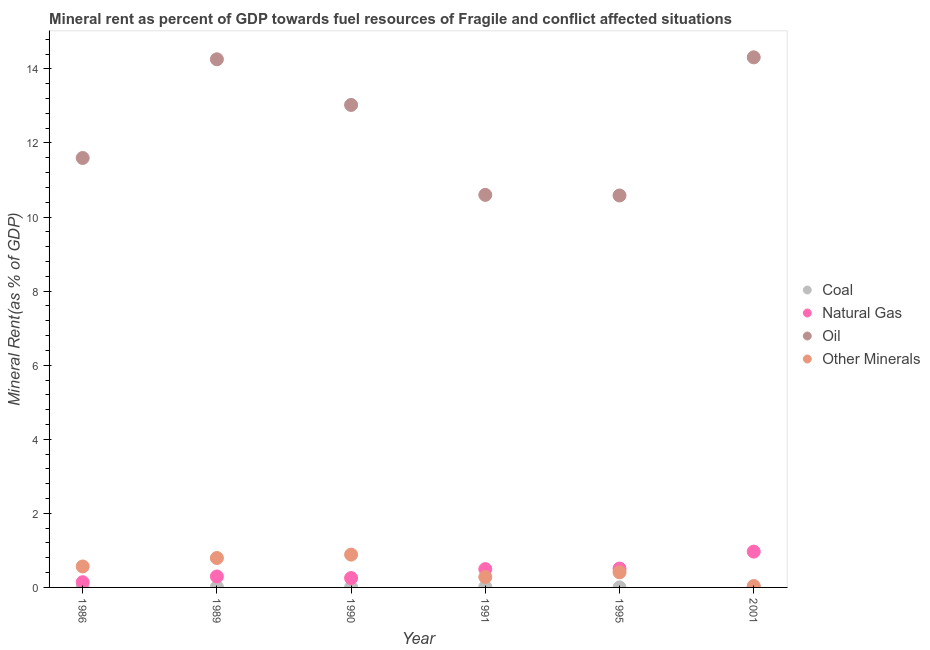Is the number of dotlines equal to the number of legend labels?
Offer a very short reply. Yes. What is the  rent of other minerals in 1995?
Offer a very short reply. 0.41. Across all years, what is the maximum natural gas rent?
Your answer should be compact. 0.97. Across all years, what is the minimum oil rent?
Give a very brief answer. 10.58. What is the total natural gas rent in the graph?
Your response must be concise. 2.66. What is the difference between the  rent of other minerals in 1986 and that in 2001?
Your answer should be compact. 0.53. What is the difference between the coal rent in 1989 and the oil rent in 1991?
Provide a succinct answer. -10.59. What is the average  rent of other minerals per year?
Give a very brief answer. 0.5. In the year 1995, what is the difference between the  rent of other minerals and coal rent?
Make the answer very short. 0.41. In how many years, is the coal rent greater than 8 %?
Make the answer very short. 0. What is the ratio of the natural gas rent in 1989 to that in 1991?
Keep it short and to the point. 0.6. Is the natural gas rent in 1989 less than that in 1995?
Your response must be concise. Yes. Is the difference between the  rent of other minerals in 1989 and 1991 greater than the difference between the oil rent in 1989 and 1991?
Make the answer very short. No. What is the difference between the highest and the second highest natural gas rent?
Give a very brief answer. 0.46. What is the difference between the highest and the lowest coal rent?
Your response must be concise. 0.01. In how many years, is the  rent of other minerals greater than the average  rent of other minerals taken over all years?
Provide a succinct answer. 3. Is the sum of the oil rent in 1989 and 2001 greater than the maximum natural gas rent across all years?
Provide a short and direct response. Yes. Is it the case that in every year, the sum of the coal rent and  rent of other minerals is greater than the sum of natural gas rent and oil rent?
Keep it short and to the point. No. Is it the case that in every year, the sum of the coal rent and natural gas rent is greater than the oil rent?
Your response must be concise. No. Does the coal rent monotonically increase over the years?
Provide a short and direct response. No. Is the coal rent strictly greater than the oil rent over the years?
Ensure brevity in your answer.  No. Is the  rent of other minerals strictly less than the coal rent over the years?
Make the answer very short. No. Are the values on the major ticks of Y-axis written in scientific E-notation?
Give a very brief answer. No. How are the legend labels stacked?
Your response must be concise. Vertical. What is the title of the graph?
Offer a very short reply. Mineral rent as percent of GDP towards fuel resources of Fragile and conflict affected situations. What is the label or title of the X-axis?
Offer a terse response. Year. What is the label or title of the Y-axis?
Your answer should be compact. Mineral Rent(as % of GDP). What is the Mineral Rent(as % of GDP) of Coal in 1986?
Your answer should be very brief. 0.01. What is the Mineral Rent(as % of GDP) of Natural Gas in 1986?
Ensure brevity in your answer.  0.14. What is the Mineral Rent(as % of GDP) in Oil in 1986?
Provide a short and direct response. 11.6. What is the Mineral Rent(as % of GDP) in Other Minerals in 1986?
Your response must be concise. 0.57. What is the Mineral Rent(as % of GDP) of Coal in 1989?
Provide a short and direct response. 0.01. What is the Mineral Rent(as % of GDP) in Natural Gas in 1989?
Offer a very short reply. 0.3. What is the Mineral Rent(as % of GDP) in Oil in 1989?
Your response must be concise. 14.26. What is the Mineral Rent(as % of GDP) in Other Minerals in 1989?
Offer a very short reply. 0.79. What is the Mineral Rent(as % of GDP) in Coal in 1990?
Ensure brevity in your answer.  0.01. What is the Mineral Rent(as % of GDP) in Natural Gas in 1990?
Keep it short and to the point. 0.25. What is the Mineral Rent(as % of GDP) in Oil in 1990?
Provide a succinct answer. 13.03. What is the Mineral Rent(as % of GDP) in Other Minerals in 1990?
Give a very brief answer. 0.89. What is the Mineral Rent(as % of GDP) in Coal in 1991?
Provide a short and direct response. 0.01. What is the Mineral Rent(as % of GDP) of Natural Gas in 1991?
Your answer should be very brief. 0.49. What is the Mineral Rent(as % of GDP) of Oil in 1991?
Your answer should be very brief. 10.6. What is the Mineral Rent(as % of GDP) of Other Minerals in 1991?
Your answer should be compact. 0.28. What is the Mineral Rent(as % of GDP) of Coal in 1995?
Offer a terse response. 0. What is the Mineral Rent(as % of GDP) in Natural Gas in 1995?
Make the answer very short. 0.51. What is the Mineral Rent(as % of GDP) in Oil in 1995?
Your answer should be compact. 10.58. What is the Mineral Rent(as % of GDP) in Other Minerals in 1995?
Your answer should be very brief. 0.41. What is the Mineral Rent(as % of GDP) in Coal in 2001?
Offer a very short reply. 0.01. What is the Mineral Rent(as % of GDP) of Natural Gas in 2001?
Your response must be concise. 0.97. What is the Mineral Rent(as % of GDP) of Oil in 2001?
Your response must be concise. 14.31. What is the Mineral Rent(as % of GDP) in Other Minerals in 2001?
Provide a short and direct response. 0.04. Across all years, what is the maximum Mineral Rent(as % of GDP) of Coal?
Give a very brief answer. 0.01. Across all years, what is the maximum Mineral Rent(as % of GDP) in Natural Gas?
Your answer should be compact. 0.97. Across all years, what is the maximum Mineral Rent(as % of GDP) in Oil?
Offer a terse response. 14.31. Across all years, what is the maximum Mineral Rent(as % of GDP) in Other Minerals?
Your answer should be very brief. 0.89. Across all years, what is the minimum Mineral Rent(as % of GDP) in Coal?
Your answer should be very brief. 0. Across all years, what is the minimum Mineral Rent(as % of GDP) of Natural Gas?
Your answer should be very brief. 0.14. Across all years, what is the minimum Mineral Rent(as % of GDP) of Oil?
Give a very brief answer. 10.58. Across all years, what is the minimum Mineral Rent(as % of GDP) in Other Minerals?
Your answer should be very brief. 0.04. What is the total Mineral Rent(as % of GDP) of Coal in the graph?
Offer a very short reply. 0.05. What is the total Mineral Rent(as % of GDP) in Natural Gas in the graph?
Offer a very short reply. 2.66. What is the total Mineral Rent(as % of GDP) in Oil in the graph?
Your answer should be very brief. 74.38. What is the total Mineral Rent(as % of GDP) of Other Minerals in the graph?
Your answer should be very brief. 2.97. What is the difference between the Mineral Rent(as % of GDP) of Coal in 1986 and that in 1989?
Your response must be concise. 0. What is the difference between the Mineral Rent(as % of GDP) of Natural Gas in 1986 and that in 1989?
Your response must be concise. -0.15. What is the difference between the Mineral Rent(as % of GDP) of Oil in 1986 and that in 1989?
Make the answer very short. -2.66. What is the difference between the Mineral Rent(as % of GDP) of Other Minerals in 1986 and that in 1989?
Offer a terse response. -0.23. What is the difference between the Mineral Rent(as % of GDP) in Coal in 1986 and that in 1990?
Your answer should be compact. 0. What is the difference between the Mineral Rent(as % of GDP) of Natural Gas in 1986 and that in 1990?
Your response must be concise. -0.11. What is the difference between the Mineral Rent(as % of GDP) of Oil in 1986 and that in 1990?
Your answer should be compact. -1.43. What is the difference between the Mineral Rent(as % of GDP) in Other Minerals in 1986 and that in 1990?
Your answer should be very brief. -0.32. What is the difference between the Mineral Rent(as % of GDP) of Coal in 1986 and that in 1991?
Your answer should be very brief. -0. What is the difference between the Mineral Rent(as % of GDP) of Natural Gas in 1986 and that in 1991?
Your answer should be very brief. -0.35. What is the difference between the Mineral Rent(as % of GDP) in Oil in 1986 and that in 1991?
Give a very brief answer. 1. What is the difference between the Mineral Rent(as % of GDP) in Other Minerals in 1986 and that in 1991?
Give a very brief answer. 0.28. What is the difference between the Mineral Rent(as % of GDP) in Coal in 1986 and that in 1995?
Offer a terse response. 0.01. What is the difference between the Mineral Rent(as % of GDP) in Natural Gas in 1986 and that in 1995?
Ensure brevity in your answer.  -0.37. What is the difference between the Mineral Rent(as % of GDP) in Other Minerals in 1986 and that in 1995?
Offer a terse response. 0.16. What is the difference between the Mineral Rent(as % of GDP) in Coal in 1986 and that in 2001?
Give a very brief answer. -0. What is the difference between the Mineral Rent(as % of GDP) in Natural Gas in 1986 and that in 2001?
Give a very brief answer. -0.83. What is the difference between the Mineral Rent(as % of GDP) of Oil in 1986 and that in 2001?
Your answer should be compact. -2.72. What is the difference between the Mineral Rent(as % of GDP) of Other Minerals in 1986 and that in 2001?
Offer a very short reply. 0.53. What is the difference between the Mineral Rent(as % of GDP) of Coal in 1989 and that in 1990?
Your answer should be compact. 0. What is the difference between the Mineral Rent(as % of GDP) of Natural Gas in 1989 and that in 1990?
Offer a terse response. 0.04. What is the difference between the Mineral Rent(as % of GDP) in Oil in 1989 and that in 1990?
Offer a very short reply. 1.23. What is the difference between the Mineral Rent(as % of GDP) in Other Minerals in 1989 and that in 1990?
Give a very brief answer. -0.09. What is the difference between the Mineral Rent(as % of GDP) of Coal in 1989 and that in 1991?
Ensure brevity in your answer.  -0.01. What is the difference between the Mineral Rent(as % of GDP) in Natural Gas in 1989 and that in 1991?
Provide a succinct answer. -0.2. What is the difference between the Mineral Rent(as % of GDP) in Oil in 1989 and that in 1991?
Your response must be concise. 3.66. What is the difference between the Mineral Rent(as % of GDP) in Other Minerals in 1989 and that in 1991?
Ensure brevity in your answer.  0.51. What is the difference between the Mineral Rent(as % of GDP) of Coal in 1989 and that in 1995?
Offer a terse response. 0.01. What is the difference between the Mineral Rent(as % of GDP) in Natural Gas in 1989 and that in 1995?
Provide a short and direct response. -0.21. What is the difference between the Mineral Rent(as % of GDP) of Oil in 1989 and that in 1995?
Provide a short and direct response. 3.68. What is the difference between the Mineral Rent(as % of GDP) in Other Minerals in 1989 and that in 1995?
Your response must be concise. 0.39. What is the difference between the Mineral Rent(as % of GDP) of Coal in 1989 and that in 2001?
Your answer should be compact. -0. What is the difference between the Mineral Rent(as % of GDP) of Natural Gas in 1989 and that in 2001?
Offer a terse response. -0.67. What is the difference between the Mineral Rent(as % of GDP) of Oil in 1989 and that in 2001?
Ensure brevity in your answer.  -0.05. What is the difference between the Mineral Rent(as % of GDP) in Other Minerals in 1989 and that in 2001?
Your answer should be very brief. 0.76. What is the difference between the Mineral Rent(as % of GDP) of Coal in 1990 and that in 1991?
Provide a succinct answer. -0.01. What is the difference between the Mineral Rent(as % of GDP) of Natural Gas in 1990 and that in 1991?
Your answer should be very brief. -0.24. What is the difference between the Mineral Rent(as % of GDP) of Oil in 1990 and that in 1991?
Provide a succinct answer. 2.43. What is the difference between the Mineral Rent(as % of GDP) of Other Minerals in 1990 and that in 1991?
Keep it short and to the point. 0.6. What is the difference between the Mineral Rent(as % of GDP) in Coal in 1990 and that in 1995?
Give a very brief answer. 0. What is the difference between the Mineral Rent(as % of GDP) in Natural Gas in 1990 and that in 1995?
Your answer should be compact. -0.26. What is the difference between the Mineral Rent(as % of GDP) of Oil in 1990 and that in 1995?
Give a very brief answer. 2.44. What is the difference between the Mineral Rent(as % of GDP) of Other Minerals in 1990 and that in 1995?
Keep it short and to the point. 0.48. What is the difference between the Mineral Rent(as % of GDP) in Coal in 1990 and that in 2001?
Your answer should be very brief. -0. What is the difference between the Mineral Rent(as % of GDP) in Natural Gas in 1990 and that in 2001?
Ensure brevity in your answer.  -0.71. What is the difference between the Mineral Rent(as % of GDP) of Oil in 1990 and that in 2001?
Provide a short and direct response. -1.29. What is the difference between the Mineral Rent(as % of GDP) in Other Minerals in 1990 and that in 2001?
Ensure brevity in your answer.  0.85. What is the difference between the Mineral Rent(as % of GDP) of Coal in 1991 and that in 1995?
Your answer should be compact. 0.01. What is the difference between the Mineral Rent(as % of GDP) in Natural Gas in 1991 and that in 1995?
Provide a succinct answer. -0.02. What is the difference between the Mineral Rent(as % of GDP) in Oil in 1991 and that in 1995?
Your response must be concise. 0.02. What is the difference between the Mineral Rent(as % of GDP) of Other Minerals in 1991 and that in 1995?
Provide a succinct answer. -0.13. What is the difference between the Mineral Rent(as % of GDP) of Coal in 1991 and that in 2001?
Your response must be concise. 0. What is the difference between the Mineral Rent(as % of GDP) in Natural Gas in 1991 and that in 2001?
Provide a succinct answer. -0.47. What is the difference between the Mineral Rent(as % of GDP) in Oil in 1991 and that in 2001?
Provide a short and direct response. -3.71. What is the difference between the Mineral Rent(as % of GDP) of Other Minerals in 1991 and that in 2001?
Offer a terse response. 0.24. What is the difference between the Mineral Rent(as % of GDP) of Coal in 1995 and that in 2001?
Your answer should be compact. -0.01. What is the difference between the Mineral Rent(as % of GDP) of Natural Gas in 1995 and that in 2001?
Your answer should be very brief. -0.46. What is the difference between the Mineral Rent(as % of GDP) of Oil in 1995 and that in 2001?
Provide a short and direct response. -3.73. What is the difference between the Mineral Rent(as % of GDP) of Other Minerals in 1995 and that in 2001?
Your response must be concise. 0.37. What is the difference between the Mineral Rent(as % of GDP) of Coal in 1986 and the Mineral Rent(as % of GDP) of Natural Gas in 1989?
Offer a terse response. -0.29. What is the difference between the Mineral Rent(as % of GDP) of Coal in 1986 and the Mineral Rent(as % of GDP) of Oil in 1989?
Offer a terse response. -14.25. What is the difference between the Mineral Rent(as % of GDP) of Coal in 1986 and the Mineral Rent(as % of GDP) of Other Minerals in 1989?
Offer a terse response. -0.78. What is the difference between the Mineral Rent(as % of GDP) of Natural Gas in 1986 and the Mineral Rent(as % of GDP) of Oil in 1989?
Your answer should be very brief. -14.12. What is the difference between the Mineral Rent(as % of GDP) of Natural Gas in 1986 and the Mineral Rent(as % of GDP) of Other Minerals in 1989?
Your answer should be compact. -0.65. What is the difference between the Mineral Rent(as % of GDP) in Oil in 1986 and the Mineral Rent(as % of GDP) in Other Minerals in 1989?
Offer a very short reply. 10.8. What is the difference between the Mineral Rent(as % of GDP) in Coal in 1986 and the Mineral Rent(as % of GDP) in Natural Gas in 1990?
Your response must be concise. -0.24. What is the difference between the Mineral Rent(as % of GDP) of Coal in 1986 and the Mineral Rent(as % of GDP) of Oil in 1990?
Give a very brief answer. -13.02. What is the difference between the Mineral Rent(as % of GDP) in Coal in 1986 and the Mineral Rent(as % of GDP) in Other Minerals in 1990?
Offer a terse response. -0.88. What is the difference between the Mineral Rent(as % of GDP) in Natural Gas in 1986 and the Mineral Rent(as % of GDP) in Oil in 1990?
Your response must be concise. -12.89. What is the difference between the Mineral Rent(as % of GDP) in Natural Gas in 1986 and the Mineral Rent(as % of GDP) in Other Minerals in 1990?
Make the answer very short. -0.75. What is the difference between the Mineral Rent(as % of GDP) in Oil in 1986 and the Mineral Rent(as % of GDP) in Other Minerals in 1990?
Make the answer very short. 10.71. What is the difference between the Mineral Rent(as % of GDP) in Coal in 1986 and the Mineral Rent(as % of GDP) in Natural Gas in 1991?
Provide a short and direct response. -0.48. What is the difference between the Mineral Rent(as % of GDP) in Coal in 1986 and the Mineral Rent(as % of GDP) in Oil in 1991?
Offer a terse response. -10.59. What is the difference between the Mineral Rent(as % of GDP) in Coal in 1986 and the Mineral Rent(as % of GDP) in Other Minerals in 1991?
Your answer should be very brief. -0.27. What is the difference between the Mineral Rent(as % of GDP) in Natural Gas in 1986 and the Mineral Rent(as % of GDP) in Oil in 1991?
Keep it short and to the point. -10.46. What is the difference between the Mineral Rent(as % of GDP) of Natural Gas in 1986 and the Mineral Rent(as % of GDP) of Other Minerals in 1991?
Keep it short and to the point. -0.14. What is the difference between the Mineral Rent(as % of GDP) in Oil in 1986 and the Mineral Rent(as % of GDP) in Other Minerals in 1991?
Your answer should be compact. 11.31. What is the difference between the Mineral Rent(as % of GDP) of Coal in 1986 and the Mineral Rent(as % of GDP) of Natural Gas in 1995?
Provide a succinct answer. -0.5. What is the difference between the Mineral Rent(as % of GDP) in Coal in 1986 and the Mineral Rent(as % of GDP) in Oil in 1995?
Ensure brevity in your answer.  -10.57. What is the difference between the Mineral Rent(as % of GDP) in Coal in 1986 and the Mineral Rent(as % of GDP) in Other Minerals in 1995?
Your response must be concise. -0.4. What is the difference between the Mineral Rent(as % of GDP) in Natural Gas in 1986 and the Mineral Rent(as % of GDP) in Oil in 1995?
Offer a terse response. -10.44. What is the difference between the Mineral Rent(as % of GDP) in Natural Gas in 1986 and the Mineral Rent(as % of GDP) in Other Minerals in 1995?
Offer a terse response. -0.27. What is the difference between the Mineral Rent(as % of GDP) of Oil in 1986 and the Mineral Rent(as % of GDP) of Other Minerals in 1995?
Provide a short and direct response. 11.19. What is the difference between the Mineral Rent(as % of GDP) of Coal in 1986 and the Mineral Rent(as % of GDP) of Natural Gas in 2001?
Your answer should be very brief. -0.96. What is the difference between the Mineral Rent(as % of GDP) in Coal in 1986 and the Mineral Rent(as % of GDP) in Oil in 2001?
Provide a succinct answer. -14.3. What is the difference between the Mineral Rent(as % of GDP) of Coal in 1986 and the Mineral Rent(as % of GDP) of Other Minerals in 2001?
Your response must be concise. -0.03. What is the difference between the Mineral Rent(as % of GDP) of Natural Gas in 1986 and the Mineral Rent(as % of GDP) of Oil in 2001?
Your answer should be compact. -14.17. What is the difference between the Mineral Rent(as % of GDP) of Natural Gas in 1986 and the Mineral Rent(as % of GDP) of Other Minerals in 2001?
Provide a short and direct response. 0.1. What is the difference between the Mineral Rent(as % of GDP) in Oil in 1986 and the Mineral Rent(as % of GDP) in Other Minerals in 2001?
Give a very brief answer. 11.56. What is the difference between the Mineral Rent(as % of GDP) in Coal in 1989 and the Mineral Rent(as % of GDP) in Natural Gas in 1990?
Your answer should be very brief. -0.25. What is the difference between the Mineral Rent(as % of GDP) in Coal in 1989 and the Mineral Rent(as % of GDP) in Oil in 1990?
Your answer should be compact. -13.02. What is the difference between the Mineral Rent(as % of GDP) in Coal in 1989 and the Mineral Rent(as % of GDP) in Other Minerals in 1990?
Offer a terse response. -0.88. What is the difference between the Mineral Rent(as % of GDP) of Natural Gas in 1989 and the Mineral Rent(as % of GDP) of Oil in 1990?
Ensure brevity in your answer.  -12.73. What is the difference between the Mineral Rent(as % of GDP) in Natural Gas in 1989 and the Mineral Rent(as % of GDP) in Other Minerals in 1990?
Provide a short and direct response. -0.59. What is the difference between the Mineral Rent(as % of GDP) in Oil in 1989 and the Mineral Rent(as % of GDP) in Other Minerals in 1990?
Offer a very short reply. 13.37. What is the difference between the Mineral Rent(as % of GDP) of Coal in 1989 and the Mineral Rent(as % of GDP) of Natural Gas in 1991?
Offer a very short reply. -0.49. What is the difference between the Mineral Rent(as % of GDP) in Coal in 1989 and the Mineral Rent(as % of GDP) in Oil in 1991?
Offer a very short reply. -10.59. What is the difference between the Mineral Rent(as % of GDP) in Coal in 1989 and the Mineral Rent(as % of GDP) in Other Minerals in 1991?
Your response must be concise. -0.27. What is the difference between the Mineral Rent(as % of GDP) in Natural Gas in 1989 and the Mineral Rent(as % of GDP) in Oil in 1991?
Your answer should be very brief. -10.3. What is the difference between the Mineral Rent(as % of GDP) of Natural Gas in 1989 and the Mineral Rent(as % of GDP) of Other Minerals in 1991?
Provide a succinct answer. 0.01. What is the difference between the Mineral Rent(as % of GDP) in Oil in 1989 and the Mineral Rent(as % of GDP) in Other Minerals in 1991?
Keep it short and to the point. 13.98. What is the difference between the Mineral Rent(as % of GDP) in Coal in 1989 and the Mineral Rent(as % of GDP) in Natural Gas in 1995?
Your answer should be compact. -0.5. What is the difference between the Mineral Rent(as % of GDP) in Coal in 1989 and the Mineral Rent(as % of GDP) in Oil in 1995?
Keep it short and to the point. -10.57. What is the difference between the Mineral Rent(as % of GDP) in Coal in 1989 and the Mineral Rent(as % of GDP) in Other Minerals in 1995?
Offer a terse response. -0.4. What is the difference between the Mineral Rent(as % of GDP) in Natural Gas in 1989 and the Mineral Rent(as % of GDP) in Oil in 1995?
Keep it short and to the point. -10.29. What is the difference between the Mineral Rent(as % of GDP) in Natural Gas in 1989 and the Mineral Rent(as % of GDP) in Other Minerals in 1995?
Give a very brief answer. -0.11. What is the difference between the Mineral Rent(as % of GDP) in Oil in 1989 and the Mineral Rent(as % of GDP) in Other Minerals in 1995?
Provide a short and direct response. 13.85. What is the difference between the Mineral Rent(as % of GDP) of Coal in 1989 and the Mineral Rent(as % of GDP) of Natural Gas in 2001?
Give a very brief answer. -0.96. What is the difference between the Mineral Rent(as % of GDP) in Coal in 1989 and the Mineral Rent(as % of GDP) in Oil in 2001?
Offer a very short reply. -14.3. What is the difference between the Mineral Rent(as % of GDP) of Coal in 1989 and the Mineral Rent(as % of GDP) of Other Minerals in 2001?
Offer a terse response. -0.03. What is the difference between the Mineral Rent(as % of GDP) in Natural Gas in 1989 and the Mineral Rent(as % of GDP) in Oil in 2001?
Offer a terse response. -14.02. What is the difference between the Mineral Rent(as % of GDP) of Natural Gas in 1989 and the Mineral Rent(as % of GDP) of Other Minerals in 2001?
Provide a short and direct response. 0.26. What is the difference between the Mineral Rent(as % of GDP) of Oil in 1989 and the Mineral Rent(as % of GDP) of Other Minerals in 2001?
Provide a short and direct response. 14.22. What is the difference between the Mineral Rent(as % of GDP) of Coal in 1990 and the Mineral Rent(as % of GDP) of Natural Gas in 1991?
Your answer should be compact. -0.49. What is the difference between the Mineral Rent(as % of GDP) of Coal in 1990 and the Mineral Rent(as % of GDP) of Oil in 1991?
Offer a very short reply. -10.59. What is the difference between the Mineral Rent(as % of GDP) of Coal in 1990 and the Mineral Rent(as % of GDP) of Other Minerals in 1991?
Offer a terse response. -0.28. What is the difference between the Mineral Rent(as % of GDP) in Natural Gas in 1990 and the Mineral Rent(as % of GDP) in Oil in 1991?
Your answer should be very brief. -10.35. What is the difference between the Mineral Rent(as % of GDP) of Natural Gas in 1990 and the Mineral Rent(as % of GDP) of Other Minerals in 1991?
Provide a short and direct response. -0.03. What is the difference between the Mineral Rent(as % of GDP) of Oil in 1990 and the Mineral Rent(as % of GDP) of Other Minerals in 1991?
Your answer should be compact. 12.75. What is the difference between the Mineral Rent(as % of GDP) of Coal in 1990 and the Mineral Rent(as % of GDP) of Natural Gas in 1995?
Offer a terse response. -0.5. What is the difference between the Mineral Rent(as % of GDP) of Coal in 1990 and the Mineral Rent(as % of GDP) of Oil in 1995?
Keep it short and to the point. -10.58. What is the difference between the Mineral Rent(as % of GDP) in Coal in 1990 and the Mineral Rent(as % of GDP) in Other Minerals in 1995?
Your answer should be compact. -0.4. What is the difference between the Mineral Rent(as % of GDP) of Natural Gas in 1990 and the Mineral Rent(as % of GDP) of Oil in 1995?
Your response must be concise. -10.33. What is the difference between the Mineral Rent(as % of GDP) in Natural Gas in 1990 and the Mineral Rent(as % of GDP) in Other Minerals in 1995?
Your answer should be very brief. -0.15. What is the difference between the Mineral Rent(as % of GDP) in Oil in 1990 and the Mineral Rent(as % of GDP) in Other Minerals in 1995?
Make the answer very short. 12.62. What is the difference between the Mineral Rent(as % of GDP) in Coal in 1990 and the Mineral Rent(as % of GDP) in Natural Gas in 2001?
Make the answer very short. -0.96. What is the difference between the Mineral Rent(as % of GDP) of Coal in 1990 and the Mineral Rent(as % of GDP) of Oil in 2001?
Your response must be concise. -14.31. What is the difference between the Mineral Rent(as % of GDP) in Coal in 1990 and the Mineral Rent(as % of GDP) in Other Minerals in 2001?
Keep it short and to the point. -0.03. What is the difference between the Mineral Rent(as % of GDP) in Natural Gas in 1990 and the Mineral Rent(as % of GDP) in Oil in 2001?
Your response must be concise. -14.06. What is the difference between the Mineral Rent(as % of GDP) of Natural Gas in 1990 and the Mineral Rent(as % of GDP) of Other Minerals in 2001?
Keep it short and to the point. 0.22. What is the difference between the Mineral Rent(as % of GDP) of Oil in 1990 and the Mineral Rent(as % of GDP) of Other Minerals in 2001?
Provide a succinct answer. 12.99. What is the difference between the Mineral Rent(as % of GDP) in Coal in 1991 and the Mineral Rent(as % of GDP) in Natural Gas in 1995?
Offer a very short reply. -0.5. What is the difference between the Mineral Rent(as % of GDP) of Coal in 1991 and the Mineral Rent(as % of GDP) of Oil in 1995?
Your answer should be compact. -10.57. What is the difference between the Mineral Rent(as % of GDP) of Coal in 1991 and the Mineral Rent(as % of GDP) of Other Minerals in 1995?
Provide a short and direct response. -0.39. What is the difference between the Mineral Rent(as % of GDP) of Natural Gas in 1991 and the Mineral Rent(as % of GDP) of Oil in 1995?
Your answer should be very brief. -10.09. What is the difference between the Mineral Rent(as % of GDP) of Natural Gas in 1991 and the Mineral Rent(as % of GDP) of Other Minerals in 1995?
Give a very brief answer. 0.09. What is the difference between the Mineral Rent(as % of GDP) of Oil in 1991 and the Mineral Rent(as % of GDP) of Other Minerals in 1995?
Your response must be concise. 10.19. What is the difference between the Mineral Rent(as % of GDP) in Coal in 1991 and the Mineral Rent(as % of GDP) in Natural Gas in 2001?
Ensure brevity in your answer.  -0.95. What is the difference between the Mineral Rent(as % of GDP) in Coal in 1991 and the Mineral Rent(as % of GDP) in Oil in 2001?
Offer a terse response. -14.3. What is the difference between the Mineral Rent(as % of GDP) of Coal in 1991 and the Mineral Rent(as % of GDP) of Other Minerals in 2001?
Your answer should be very brief. -0.02. What is the difference between the Mineral Rent(as % of GDP) of Natural Gas in 1991 and the Mineral Rent(as % of GDP) of Oil in 2001?
Your answer should be very brief. -13.82. What is the difference between the Mineral Rent(as % of GDP) in Natural Gas in 1991 and the Mineral Rent(as % of GDP) in Other Minerals in 2001?
Offer a very short reply. 0.46. What is the difference between the Mineral Rent(as % of GDP) in Oil in 1991 and the Mineral Rent(as % of GDP) in Other Minerals in 2001?
Make the answer very short. 10.56. What is the difference between the Mineral Rent(as % of GDP) of Coal in 1995 and the Mineral Rent(as % of GDP) of Natural Gas in 2001?
Keep it short and to the point. -0.97. What is the difference between the Mineral Rent(as % of GDP) of Coal in 1995 and the Mineral Rent(as % of GDP) of Oil in 2001?
Give a very brief answer. -14.31. What is the difference between the Mineral Rent(as % of GDP) of Coal in 1995 and the Mineral Rent(as % of GDP) of Other Minerals in 2001?
Keep it short and to the point. -0.04. What is the difference between the Mineral Rent(as % of GDP) in Natural Gas in 1995 and the Mineral Rent(as % of GDP) in Oil in 2001?
Your answer should be compact. -13.8. What is the difference between the Mineral Rent(as % of GDP) of Natural Gas in 1995 and the Mineral Rent(as % of GDP) of Other Minerals in 2001?
Give a very brief answer. 0.47. What is the difference between the Mineral Rent(as % of GDP) in Oil in 1995 and the Mineral Rent(as % of GDP) in Other Minerals in 2001?
Offer a terse response. 10.54. What is the average Mineral Rent(as % of GDP) of Coal per year?
Ensure brevity in your answer.  0.01. What is the average Mineral Rent(as % of GDP) in Natural Gas per year?
Your answer should be compact. 0.44. What is the average Mineral Rent(as % of GDP) of Oil per year?
Keep it short and to the point. 12.4. What is the average Mineral Rent(as % of GDP) in Other Minerals per year?
Your answer should be very brief. 0.5. In the year 1986, what is the difference between the Mineral Rent(as % of GDP) in Coal and Mineral Rent(as % of GDP) in Natural Gas?
Give a very brief answer. -0.13. In the year 1986, what is the difference between the Mineral Rent(as % of GDP) of Coal and Mineral Rent(as % of GDP) of Oil?
Keep it short and to the point. -11.59. In the year 1986, what is the difference between the Mineral Rent(as % of GDP) of Coal and Mineral Rent(as % of GDP) of Other Minerals?
Offer a terse response. -0.56. In the year 1986, what is the difference between the Mineral Rent(as % of GDP) in Natural Gas and Mineral Rent(as % of GDP) in Oil?
Give a very brief answer. -11.45. In the year 1986, what is the difference between the Mineral Rent(as % of GDP) of Natural Gas and Mineral Rent(as % of GDP) of Other Minerals?
Keep it short and to the point. -0.42. In the year 1986, what is the difference between the Mineral Rent(as % of GDP) in Oil and Mineral Rent(as % of GDP) in Other Minerals?
Ensure brevity in your answer.  11.03. In the year 1989, what is the difference between the Mineral Rent(as % of GDP) in Coal and Mineral Rent(as % of GDP) in Natural Gas?
Offer a terse response. -0.29. In the year 1989, what is the difference between the Mineral Rent(as % of GDP) of Coal and Mineral Rent(as % of GDP) of Oil?
Offer a very short reply. -14.25. In the year 1989, what is the difference between the Mineral Rent(as % of GDP) of Coal and Mineral Rent(as % of GDP) of Other Minerals?
Make the answer very short. -0.79. In the year 1989, what is the difference between the Mineral Rent(as % of GDP) of Natural Gas and Mineral Rent(as % of GDP) of Oil?
Provide a succinct answer. -13.96. In the year 1989, what is the difference between the Mineral Rent(as % of GDP) in Natural Gas and Mineral Rent(as % of GDP) in Other Minerals?
Keep it short and to the point. -0.5. In the year 1989, what is the difference between the Mineral Rent(as % of GDP) of Oil and Mineral Rent(as % of GDP) of Other Minerals?
Make the answer very short. 13.47. In the year 1990, what is the difference between the Mineral Rent(as % of GDP) of Coal and Mineral Rent(as % of GDP) of Natural Gas?
Provide a short and direct response. -0.25. In the year 1990, what is the difference between the Mineral Rent(as % of GDP) of Coal and Mineral Rent(as % of GDP) of Oil?
Your answer should be very brief. -13.02. In the year 1990, what is the difference between the Mineral Rent(as % of GDP) in Coal and Mineral Rent(as % of GDP) in Other Minerals?
Offer a terse response. -0.88. In the year 1990, what is the difference between the Mineral Rent(as % of GDP) of Natural Gas and Mineral Rent(as % of GDP) of Oil?
Provide a short and direct response. -12.77. In the year 1990, what is the difference between the Mineral Rent(as % of GDP) of Natural Gas and Mineral Rent(as % of GDP) of Other Minerals?
Provide a short and direct response. -0.63. In the year 1990, what is the difference between the Mineral Rent(as % of GDP) in Oil and Mineral Rent(as % of GDP) in Other Minerals?
Your response must be concise. 12.14. In the year 1991, what is the difference between the Mineral Rent(as % of GDP) in Coal and Mineral Rent(as % of GDP) in Natural Gas?
Give a very brief answer. -0.48. In the year 1991, what is the difference between the Mineral Rent(as % of GDP) in Coal and Mineral Rent(as % of GDP) in Oil?
Keep it short and to the point. -10.58. In the year 1991, what is the difference between the Mineral Rent(as % of GDP) of Coal and Mineral Rent(as % of GDP) of Other Minerals?
Offer a very short reply. -0.27. In the year 1991, what is the difference between the Mineral Rent(as % of GDP) in Natural Gas and Mineral Rent(as % of GDP) in Oil?
Your response must be concise. -10.1. In the year 1991, what is the difference between the Mineral Rent(as % of GDP) of Natural Gas and Mineral Rent(as % of GDP) of Other Minerals?
Provide a succinct answer. 0.21. In the year 1991, what is the difference between the Mineral Rent(as % of GDP) of Oil and Mineral Rent(as % of GDP) of Other Minerals?
Provide a short and direct response. 10.32. In the year 1995, what is the difference between the Mineral Rent(as % of GDP) of Coal and Mineral Rent(as % of GDP) of Natural Gas?
Offer a terse response. -0.51. In the year 1995, what is the difference between the Mineral Rent(as % of GDP) in Coal and Mineral Rent(as % of GDP) in Oil?
Ensure brevity in your answer.  -10.58. In the year 1995, what is the difference between the Mineral Rent(as % of GDP) of Coal and Mineral Rent(as % of GDP) of Other Minerals?
Provide a short and direct response. -0.41. In the year 1995, what is the difference between the Mineral Rent(as % of GDP) in Natural Gas and Mineral Rent(as % of GDP) in Oil?
Your answer should be compact. -10.07. In the year 1995, what is the difference between the Mineral Rent(as % of GDP) in Natural Gas and Mineral Rent(as % of GDP) in Other Minerals?
Keep it short and to the point. 0.1. In the year 1995, what is the difference between the Mineral Rent(as % of GDP) in Oil and Mineral Rent(as % of GDP) in Other Minerals?
Provide a succinct answer. 10.17. In the year 2001, what is the difference between the Mineral Rent(as % of GDP) of Coal and Mineral Rent(as % of GDP) of Natural Gas?
Keep it short and to the point. -0.96. In the year 2001, what is the difference between the Mineral Rent(as % of GDP) of Coal and Mineral Rent(as % of GDP) of Oil?
Your answer should be very brief. -14.3. In the year 2001, what is the difference between the Mineral Rent(as % of GDP) of Coal and Mineral Rent(as % of GDP) of Other Minerals?
Your response must be concise. -0.03. In the year 2001, what is the difference between the Mineral Rent(as % of GDP) of Natural Gas and Mineral Rent(as % of GDP) of Oil?
Offer a very short reply. -13.35. In the year 2001, what is the difference between the Mineral Rent(as % of GDP) in Natural Gas and Mineral Rent(as % of GDP) in Other Minerals?
Provide a succinct answer. 0.93. In the year 2001, what is the difference between the Mineral Rent(as % of GDP) in Oil and Mineral Rent(as % of GDP) in Other Minerals?
Give a very brief answer. 14.28. What is the ratio of the Mineral Rent(as % of GDP) of Coal in 1986 to that in 1989?
Your response must be concise. 1.18. What is the ratio of the Mineral Rent(as % of GDP) in Natural Gas in 1986 to that in 1989?
Ensure brevity in your answer.  0.48. What is the ratio of the Mineral Rent(as % of GDP) in Oil in 1986 to that in 1989?
Your answer should be very brief. 0.81. What is the ratio of the Mineral Rent(as % of GDP) of Other Minerals in 1986 to that in 1989?
Your answer should be compact. 0.71. What is the ratio of the Mineral Rent(as % of GDP) of Coal in 1986 to that in 1990?
Keep it short and to the point. 1.83. What is the ratio of the Mineral Rent(as % of GDP) in Natural Gas in 1986 to that in 1990?
Your answer should be compact. 0.56. What is the ratio of the Mineral Rent(as % of GDP) in Oil in 1986 to that in 1990?
Ensure brevity in your answer.  0.89. What is the ratio of the Mineral Rent(as % of GDP) of Other Minerals in 1986 to that in 1990?
Make the answer very short. 0.64. What is the ratio of the Mineral Rent(as % of GDP) in Coal in 1986 to that in 1991?
Give a very brief answer. 0.68. What is the ratio of the Mineral Rent(as % of GDP) in Natural Gas in 1986 to that in 1991?
Ensure brevity in your answer.  0.29. What is the ratio of the Mineral Rent(as % of GDP) in Oil in 1986 to that in 1991?
Your answer should be compact. 1.09. What is the ratio of the Mineral Rent(as % of GDP) of Other Minerals in 1986 to that in 1991?
Provide a succinct answer. 2.01. What is the ratio of the Mineral Rent(as % of GDP) of Coal in 1986 to that in 1995?
Ensure brevity in your answer.  10.88. What is the ratio of the Mineral Rent(as % of GDP) of Natural Gas in 1986 to that in 1995?
Your response must be concise. 0.28. What is the ratio of the Mineral Rent(as % of GDP) of Oil in 1986 to that in 1995?
Your response must be concise. 1.1. What is the ratio of the Mineral Rent(as % of GDP) in Other Minerals in 1986 to that in 1995?
Your answer should be very brief. 1.38. What is the ratio of the Mineral Rent(as % of GDP) in Coal in 1986 to that in 2001?
Offer a terse response. 0.96. What is the ratio of the Mineral Rent(as % of GDP) in Natural Gas in 1986 to that in 2001?
Give a very brief answer. 0.15. What is the ratio of the Mineral Rent(as % of GDP) of Oil in 1986 to that in 2001?
Ensure brevity in your answer.  0.81. What is the ratio of the Mineral Rent(as % of GDP) of Other Minerals in 1986 to that in 2001?
Provide a succinct answer. 14.96. What is the ratio of the Mineral Rent(as % of GDP) in Coal in 1989 to that in 1990?
Your answer should be very brief. 1.55. What is the ratio of the Mineral Rent(as % of GDP) of Natural Gas in 1989 to that in 1990?
Provide a succinct answer. 1.17. What is the ratio of the Mineral Rent(as % of GDP) in Oil in 1989 to that in 1990?
Provide a succinct answer. 1.09. What is the ratio of the Mineral Rent(as % of GDP) of Other Minerals in 1989 to that in 1990?
Make the answer very short. 0.9. What is the ratio of the Mineral Rent(as % of GDP) in Coal in 1989 to that in 1991?
Your answer should be very brief. 0.58. What is the ratio of the Mineral Rent(as % of GDP) in Natural Gas in 1989 to that in 1991?
Offer a terse response. 0.6. What is the ratio of the Mineral Rent(as % of GDP) in Oil in 1989 to that in 1991?
Provide a short and direct response. 1.35. What is the ratio of the Mineral Rent(as % of GDP) in Other Minerals in 1989 to that in 1991?
Keep it short and to the point. 2.82. What is the ratio of the Mineral Rent(as % of GDP) of Coal in 1989 to that in 1995?
Provide a succinct answer. 9.24. What is the ratio of the Mineral Rent(as % of GDP) in Natural Gas in 1989 to that in 1995?
Give a very brief answer. 0.58. What is the ratio of the Mineral Rent(as % of GDP) in Oil in 1989 to that in 1995?
Your response must be concise. 1.35. What is the ratio of the Mineral Rent(as % of GDP) in Other Minerals in 1989 to that in 1995?
Make the answer very short. 1.94. What is the ratio of the Mineral Rent(as % of GDP) of Coal in 1989 to that in 2001?
Make the answer very short. 0.82. What is the ratio of the Mineral Rent(as % of GDP) of Natural Gas in 1989 to that in 2001?
Your answer should be very brief. 0.31. What is the ratio of the Mineral Rent(as % of GDP) of Oil in 1989 to that in 2001?
Your answer should be compact. 1. What is the ratio of the Mineral Rent(as % of GDP) in Other Minerals in 1989 to that in 2001?
Ensure brevity in your answer.  20.99. What is the ratio of the Mineral Rent(as % of GDP) in Coal in 1990 to that in 1991?
Your answer should be very brief. 0.37. What is the ratio of the Mineral Rent(as % of GDP) in Natural Gas in 1990 to that in 1991?
Provide a succinct answer. 0.51. What is the ratio of the Mineral Rent(as % of GDP) in Oil in 1990 to that in 1991?
Your answer should be very brief. 1.23. What is the ratio of the Mineral Rent(as % of GDP) of Other Minerals in 1990 to that in 1991?
Provide a succinct answer. 3.15. What is the ratio of the Mineral Rent(as % of GDP) in Coal in 1990 to that in 1995?
Provide a succinct answer. 5.95. What is the ratio of the Mineral Rent(as % of GDP) in Natural Gas in 1990 to that in 1995?
Provide a succinct answer. 0.5. What is the ratio of the Mineral Rent(as % of GDP) of Oil in 1990 to that in 1995?
Make the answer very short. 1.23. What is the ratio of the Mineral Rent(as % of GDP) of Other Minerals in 1990 to that in 1995?
Provide a succinct answer. 2.17. What is the ratio of the Mineral Rent(as % of GDP) of Coal in 1990 to that in 2001?
Your response must be concise. 0.53. What is the ratio of the Mineral Rent(as % of GDP) in Natural Gas in 1990 to that in 2001?
Offer a very short reply. 0.26. What is the ratio of the Mineral Rent(as % of GDP) of Oil in 1990 to that in 2001?
Ensure brevity in your answer.  0.91. What is the ratio of the Mineral Rent(as % of GDP) of Other Minerals in 1990 to that in 2001?
Your answer should be very brief. 23.43. What is the ratio of the Mineral Rent(as % of GDP) in Coal in 1991 to that in 1995?
Keep it short and to the point. 15.92. What is the ratio of the Mineral Rent(as % of GDP) in Natural Gas in 1991 to that in 1995?
Your answer should be compact. 0.97. What is the ratio of the Mineral Rent(as % of GDP) of Oil in 1991 to that in 1995?
Your answer should be very brief. 1. What is the ratio of the Mineral Rent(as % of GDP) in Other Minerals in 1991 to that in 1995?
Your answer should be compact. 0.69. What is the ratio of the Mineral Rent(as % of GDP) of Coal in 1991 to that in 2001?
Offer a terse response. 1.4. What is the ratio of the Mineral Rent(as % of GDP) in Natural Gas in 1991 to that in 2001?
Your response must be concise. 0.51. What is the ratio of the Mineral Rent(as % of GDP) of Oil in 1991 to that in 2001?
Offer a very short reply. 0.74. What is the ratio of the Mineral Rent(as % of GDP) in Other Minerals in 1991 to that in 2001?
Make the answer very short. 7.45. What is the ratio of the Mineral Rent(as % of GDP) of Coal in 1995 to that in 2001?
Give a very brief answer. 0.09. What is the ratio of the Mineral Rent(as % of GDP) of Natural Gas in 1995 to that in 2001?
Offer a very short reply. 0.53. What is the ratio of the Mineral Rent(as % of GDP) in Oil in 1995 to that in 2001?
Offer a terse response. 0.74. What is the ratio of the Mineral Rent(as % of GDP) of Other Minerals in 1995 to that in 2001?
Your answer should be very brief. 10.8. What is the difference between the highest and the second highest Mineral Rent(as % of GDP) in Coal?
Make the answer very short. 0. What is the difference between the highest and the second highest Mineral Rent(as % of GDP) in Natural Gas?
Give a very brief answer. 0.46. What is the difference between the highest and the second highest Mineral Rent(as % of GDP) in Oil?
Give a very brief answer. 0.05. What is the difference between the highest and the second highest Mineral Rent(as % of GDP) of Other Minerals?
Offer a very short reply. 0.09. What is the difference between the highest and the lowest Mineral Rent(as % of GDP) of Coal?
Offer a terse response. 0.01. What is the difference between the highest and the lowest Mineral Rent(as % of GDP) of Natural Gas?
Your answer should be compact. 0.83. What is the difference between the highest and the lowest Mineral Rent(as % of GDP) in Oil?
Make the answer very short. 3.73. What is the difference between the highest and the lowest Mineral Rent(as % of GDP) in Other Minerals?
Offer a very short reply. 0.85. 